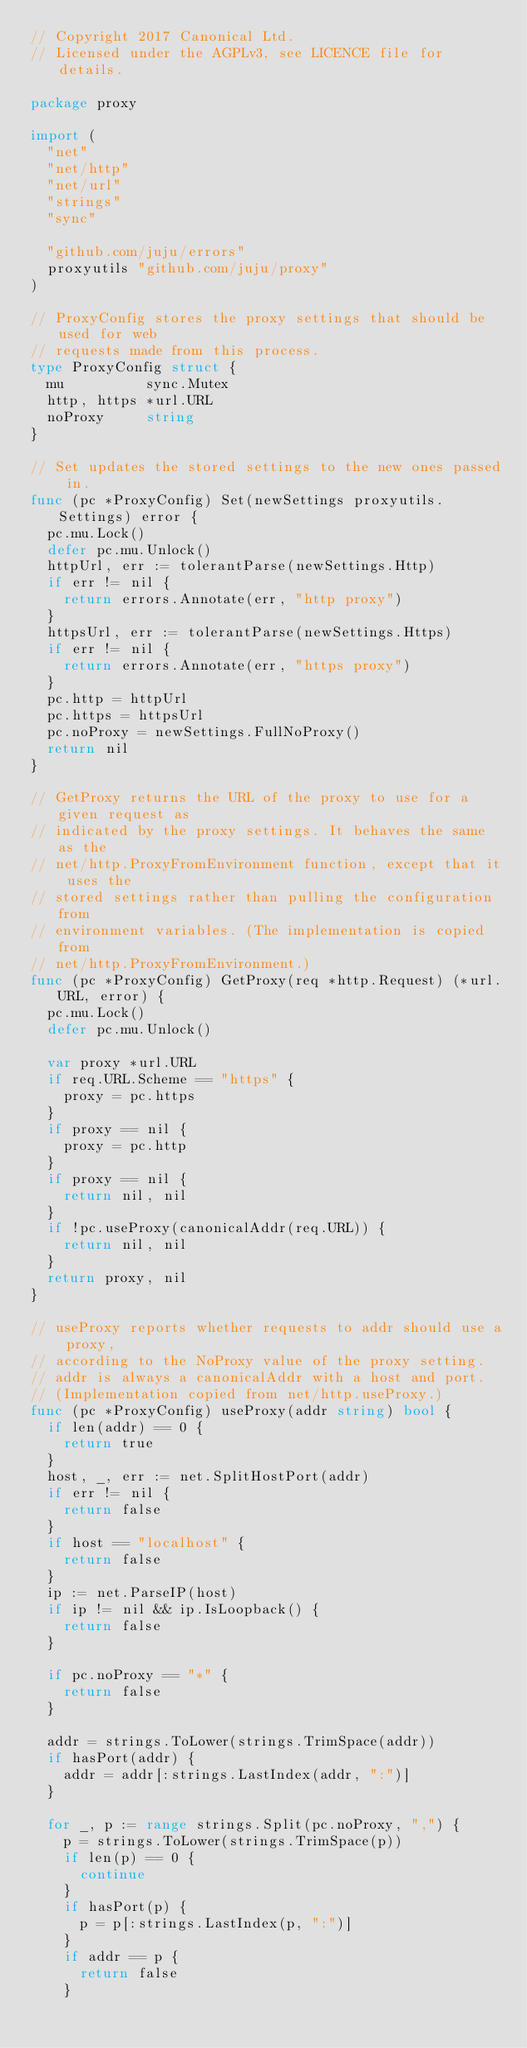<code> <loc_0><loc_0><loc_500><loc_500><_Go_>// Copyright 2017 Canonical Ltd.
// Licensed under the AGPLv3, see LICENCE file for details.

package proxy

import (
	"net"
	"net/http"
	"net/url"
	"strings"
	"sync"

	"github.com/juju/errors"
	proxyutils "github.com/juju/proxy"
)

// ProxyConfig stores the proxy settings that should be used for web
// requests made from this process.
type ProxyConfig struct {
	mu          sync.Mutex
	http, https *url.URL
	noProxy     string
}

// Set updates the stored settings to the new ones passed in.
func (pc *ProxyConfig) Set(newSettings proxyutils.Settings) error {
	pc.mu.Lock()
	defer pc.mu.Unlock()
	httpUrl, err := tolerantParse(newSettings.Http)
	if err != nil {
		return errors.Annotate(err, "http proxy")
	}
	httpsUrl, err := tolerantParse(newSettings.Https)
	if err != nil {
		return errors.Annotate(err, "https proxy")
	}
	pc.http = httpUrl
	pc.https = httpsUrl
	pc.noProxy = newSettings.FullNoProxy()
	return nil
}

// GetProxy returns the URL of the proxy to use for a given request as
// indicated by the proxy settings. It behaves the same as the
// net/http.ProxyFromEnvironment function, except that it uses the
// stored settings rather than pulling the configuration from
// environment variables. (The implementation is copied from
// net/http.ProxyFromEnvironment.)
func (pc *ProxyConfig) GetProxy(req *http.Request) (*url.URL, error) {
	pc.mu.Lock()
	defer pc.mu.Unlock()

	var proxy *url.URL
	if req.URL.Scheme == "https" {
		proxy = pc.https
	}
	if proxy == nil {
		proxy = pc.http
	}
	if proxy == nil {
		return nil, nil
	}
	if !pc.useProxy(canonicalAddr(req.URL)) {
		return nil, nil
	}
	return proxy, nil
}

// useProxy reports whether requests to addr should use a proxy,
// according to the NoProxy value of the proxy setting.
// addr is always a canonicalAddr with a host and port.
// (Implementation copied from net/http.useProxy.)
func (pc *ProxyConfig) useProxy(addr string) bool {
	if len(addr) == 0 {
		return true
	}
	host, _, err := net.SplitHostPort(addr)
	if err != nil {
		return false
	}
	if host == "localhost" {
		return false
	}
	ip := net.ParseIP(host)
	if ip != nil && ip.IsLoopback() {
		return false
	}

	if pc.noProxy == "*" {
		return false
	}

	addr = strings.ToLower(strings.TrimSpace(addr))
	if hasPort(addr) {
		addr = addr[:strings.LastIndex(addr, ":")]
	}

	for _, p := range strings.Split(pc.noProxy, ",") {
		p = strings.ToLower(strings.TrimSpace(p))
		if len(p) == 0 {
			continue
		}
		if hasPort(p) {
			p = p[:strings.LastIndex(p, ":")]
		}
		if addr == p {
			return false
		}</code> 